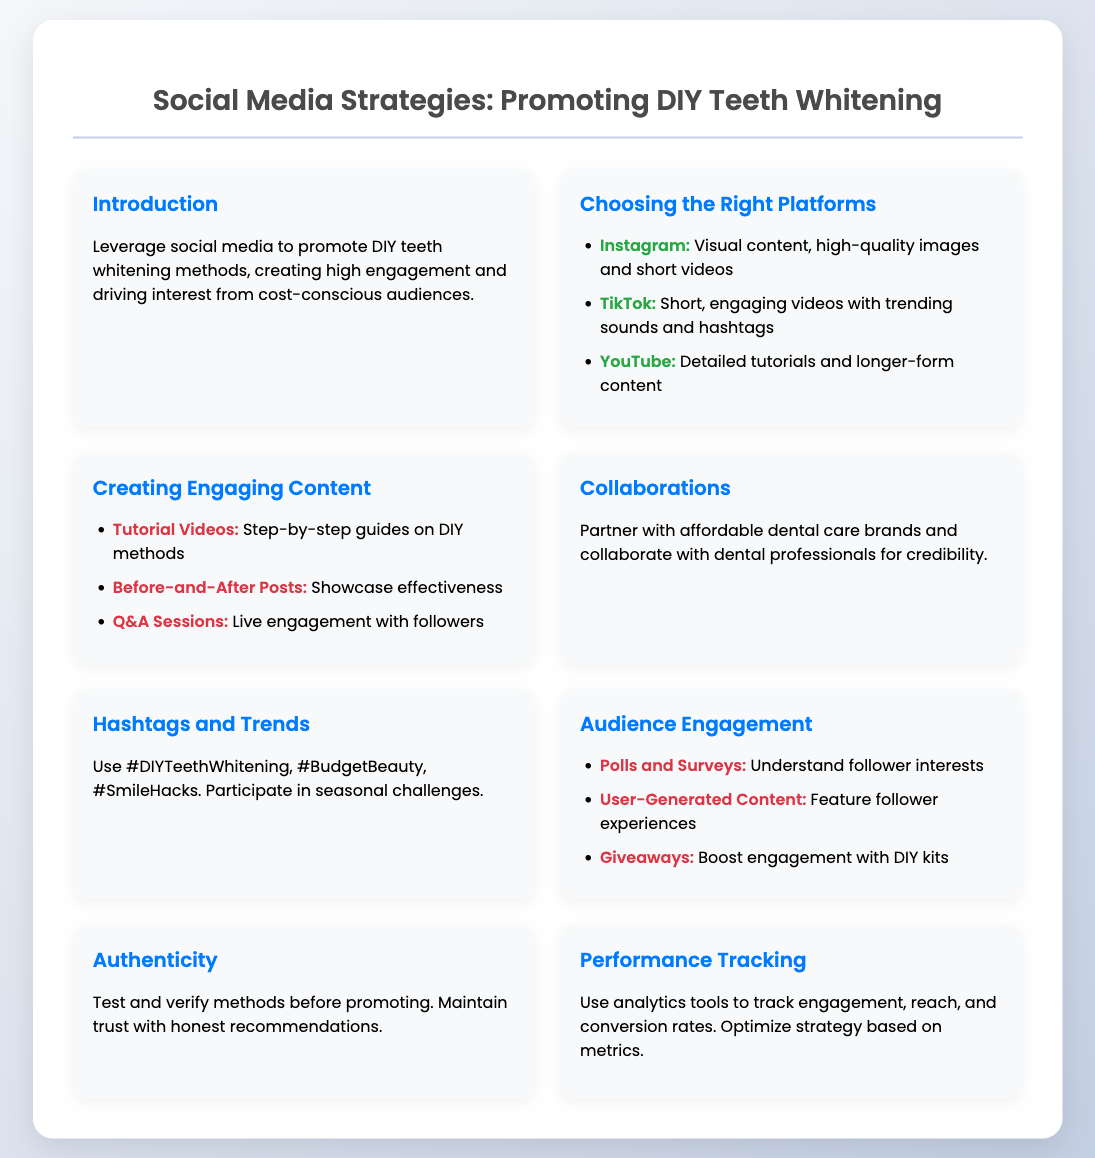What platforms are recommended for promoting DIY teeth whitening? The document lists platforms such as Instagram, TikTok, and YouTube for promoting DIY teeth whitening methods.
Answer: Instagram, TikTok, YouTube What type of content should be included for audience engagement? The document suggests using polls, user-generated content, and giveaways for audience engagement.
Answer: Polls, user-generated content, giveaways What is the importance of authenticity in promoting DIY methods? The document emphasizes the need to test and verify methods before promoting and maintaining trust with honest recommendations.
Answer: Testing and verifying methods Which engagement type showcases effectiveness visually? The document mentions before-and-after posts as an effective way to showcase the results of DIY teeth whitening methods.
Answer: Before-and-after posts How can performance be tracked according to the presentation? The document states that analytics tools should be used to track engagement, reach, and conversion rates.
Answer: Analytics tools What type of collaboration is suggested in the strategies? The document suggests partnering with affordable dental care brands and dental professionals for credibility.
Answer: Affordable dental care brands, dental professionals Which hashtag is specifically mentioned for DIY teeth whitening? The document lists #DIYTeethWhitening as a key hashtag to use for promoting DIY teeth whitening.
Answer: #DIYTeethWhitening What type of video content is suggested for creating engagement? The document recommends tutorial videos that provide step-by-step guides on DIY methods.
Answer: Tutorial videos 